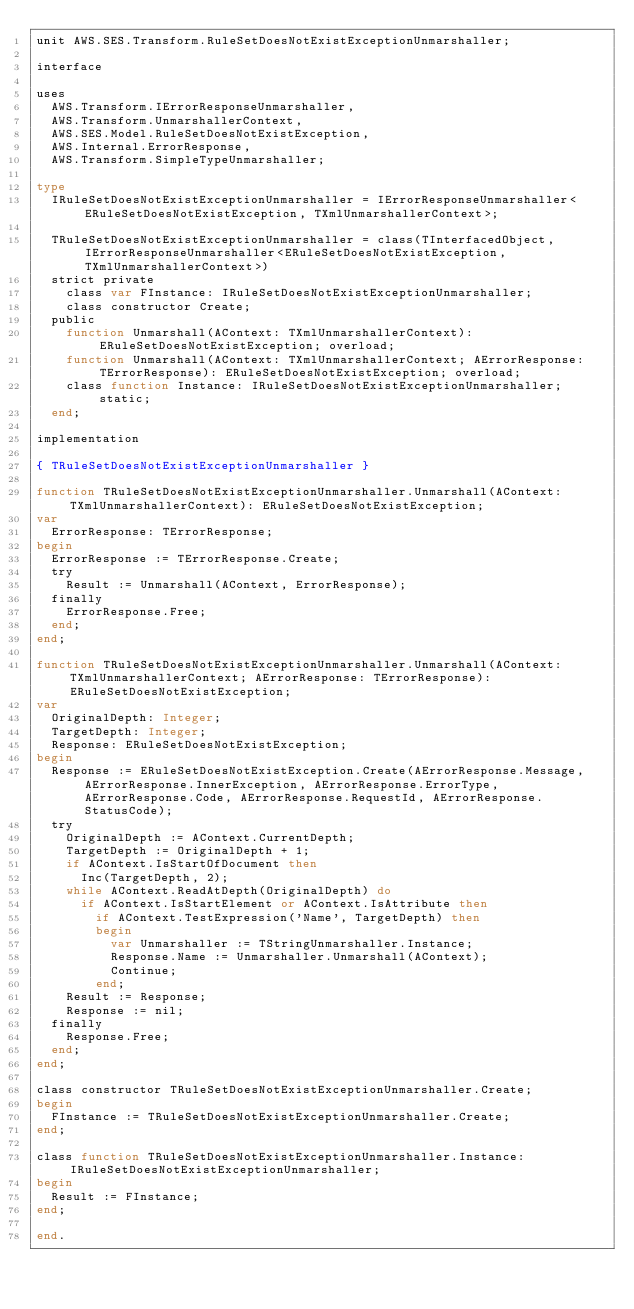Convert code to text. <code><loc_0><loc_0><loc_500><loc_500><_Pascal_>unit AWS.SES.Transform.RuleSetDoesNotExistExceptionUnmarshaller;

interface

uses
  AWS.Transform.IErrorResponseUnmarshaller, 
  AWS.Transform.UnmarshallerContext, 
  AWS.SES.Model.RuleSetDoesNotExistException, 
  AWS.Internal.ErrorResponse, 
  AWS.Transform.SimpleTypeUnmarshaller;

type
  IRuleSetDoesNotExistExceptionUnmarshaller = IErrorResponseUnmarshaller<ERuleSetDoesNotExistException, TXmlUnmarshallerContext>;
  
  TRuleSetDoesNotExistExceptionUnmarshaller = class(TInterfacedObject, IErrorResponseUnmarshaller<ERuleSetDoesNotExistException, TXmlUnmarshallerContext>)
  strict private
    class var FInstance: IRuleSetDoesNotExistExceptionUnmarshaller;
    class constructor Create;
  public
    function Unmarshall(AContext: TXmlUnmarshallerContext): ERuleSetDoesNotExistException; overload;
    function Unmarshall(AContext: TXmlUnmarshallerContext; AErrorResponse: TErrorResponse): ERuleSetDoesNotExistException; overload;
    class function Instance: IRuleSetDoesNotExistExceptionUnmarshaller; static;
  end;
  
implementation

{ TRuleSetDoesNotExistExceptionUnmarshaller }

function TRuleSetDoesNotExistExceptionUnmarshaller.Unmarshall(AContext: TXmlUnmarshallerContext): ERuleSetDoesNotExistException;
var
  ErrorResponse: TErrorResponse;
begin
  ErrorResponse := TErrorResponse.Create;
  try
    Result := Unmarshall(AContext, ErrorResponse);
  finally
    ErrorResponse.Free;
  end;
end;

function TRuleSetDoesNotExistExceptionUnmarshaller.Unmarshall(AContext: TXmlUnmarshallerContext; AErrorResponse: TErrorResponse): ERuleSetDoesNotExistException;
var
  OriginalDepth: Integer;
  TargetDepth: Integer;
  Response: ERuleSetDoesNotExistException;
begin
  Response := ERuleSetDoesNotExistException.Create(AErrorResponse.Message, AErrorResponse.InnerException, AErrorResponse.ErrorType, AErrorResponse.Code, AErrorResponse.RequestId, AErrorResponse.StatusCode);
  try
    OriginalDepth := AContext.CurrentDepth;
    TargetDepth := OriginalDepth + 1;
    if AContext.IsStartOfDocument then
      Inc(TargetDepth, 2);
    while AContext.ReadAtDepth(OriginalDepth) do
      if AContext.IsStartElement or AContext.IsAttribute then
        if AContext.TestExpression('Name', TargetDepth) then
        begin
          var Unmarshaller := TStringUnmarshaller.Instance;
          Response.Name := Unmarshaller.Unmarshall(AContext);
          Continue;
        end;
    Result := Response;
    Response := nil;
  finally
    Response.Free;
  end;
end;

class constructor TRuleSetDoesNotExistExceptionUnmarshaller.Create;
begin
  FInstance := TRuleSetDoesNotExistExceptionUnmarshaller.Create;
end;

class function TRuleSetDoesNotExistExceptionUnmarshaller.Instance: IRuleSetDoesNotExistExceptionUnmarshaller;
begin
  Result := FInstance;
end;

end.
</code> 